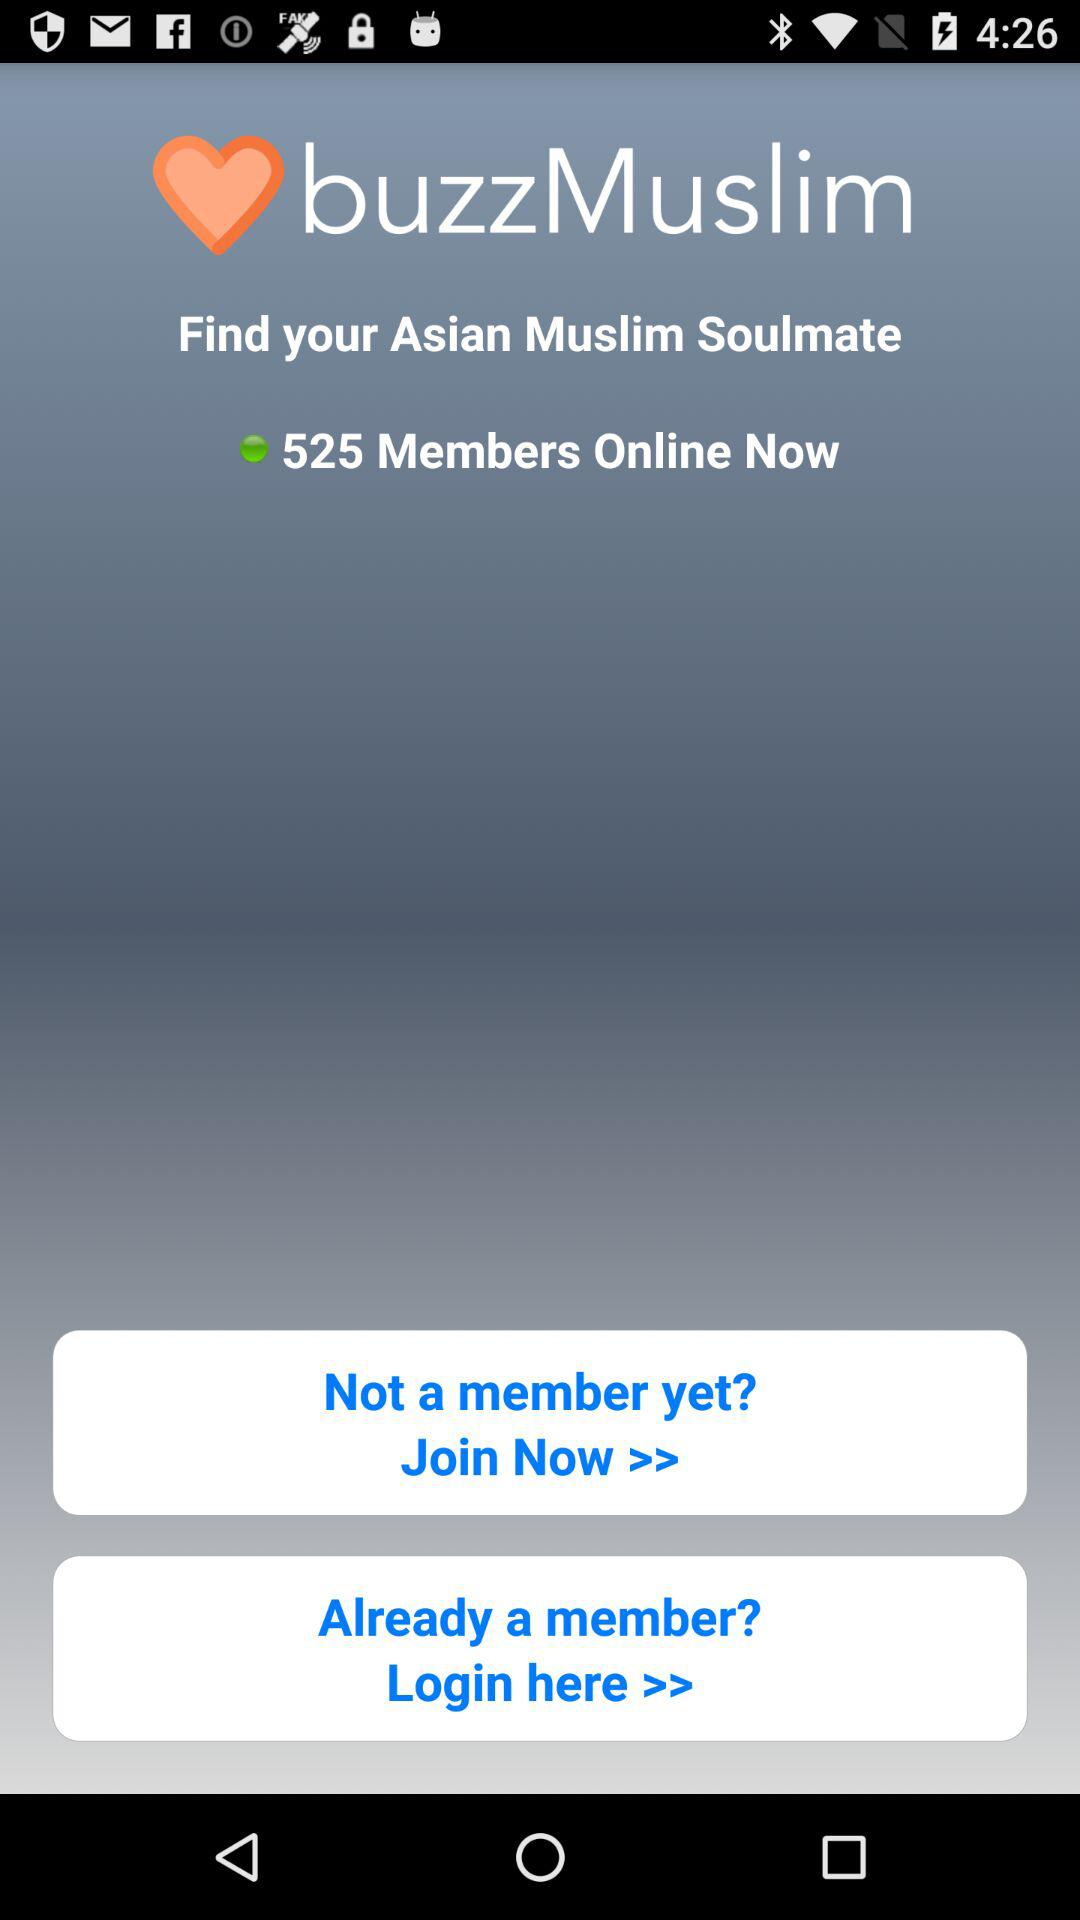How many members are online right now? There are 525 members online right now. 